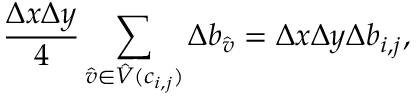<formula> <loc_0><loc_0><loc_500><loc_500>\frac { \Delta x \Delta y } { 4 } \sum _ { \hat { v } \in \hat { V } ( c _ { i , j } ) } \Delta b _ { \hat { v } } = \Delta x \Delta y \Delta b _ { i , j } ,</formula> 